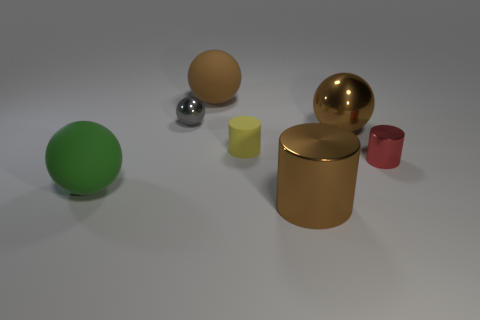Subtract all green balls. How many balls are left? 3 Subtract all gray cylinders. How many brown balls are left? 2 Subtract all green balls. How many balls are left? 3 Add 1 large brown metallic cylinders. How many objects exist? 8 Subtract all cylinders. How many objects are left? 4 Subtract 2 balls. How many balls are left? 2 Subtract all small yellow matte things. Subtract all purple matte cubes. How many objects are left? 6 Add 2 large rubber objects. How many large rubber objects are left? 4 Add 2 big red shiny balls. How many big red shiny balls exist? 2 Subtract 0 purple cubes. How many objects are left? 7 